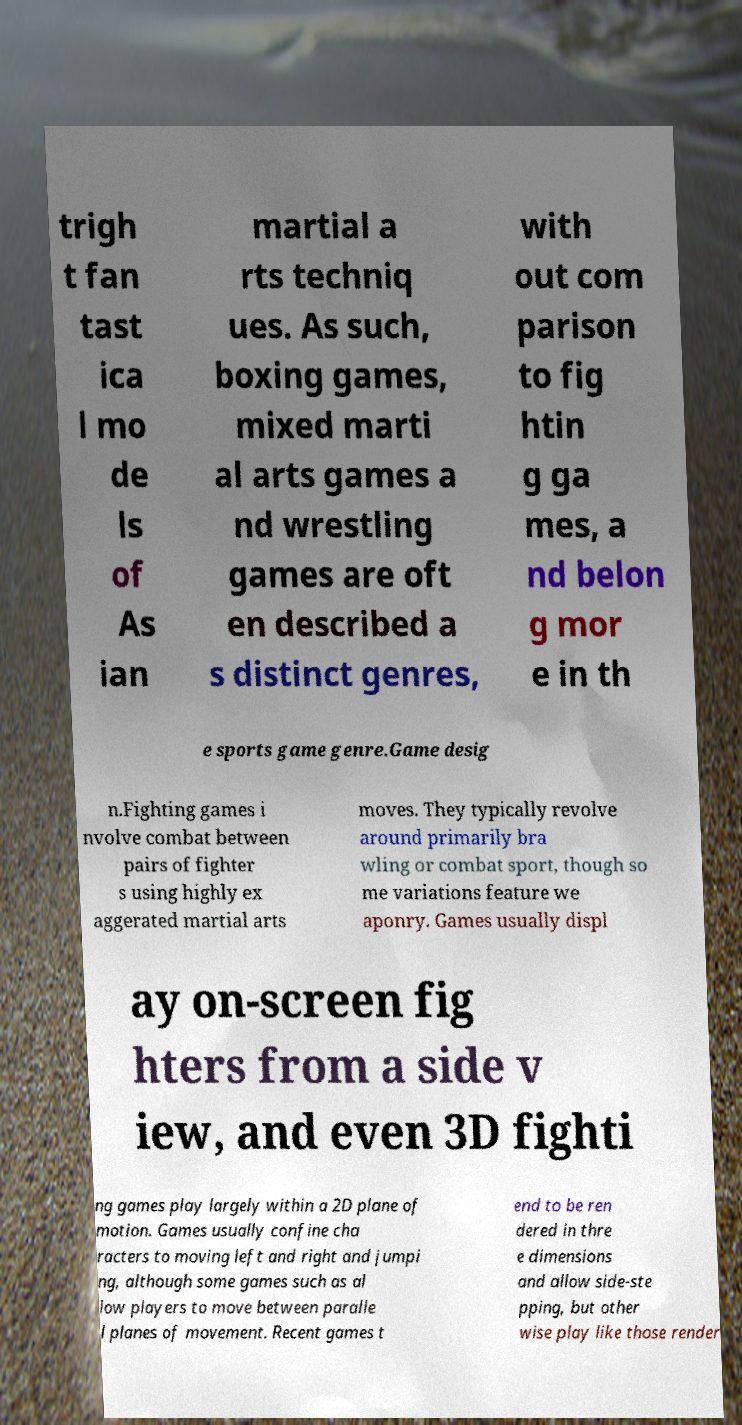There's text embedded in this image that I need extracted. Can you transcribe it verbatim? trigh t fan tast ica l mo de ls of As ian martial a rts techniq ues. As such, boxing games, mixed marti al arts games a nd wrestling games are oft en described a s distinct genres, with out com parison to fig htin g ga mes, a nd belon g mor e in th e sports game genre.Game desig n.Fighting games i nvolve combat between pairs of fighter s using highly ex aggerated martial arts moves. They typically revolve around primarily bra wling or combat sport, though so me variations feature we aponry. Games usually displ ay on-screen fig hters from a side v iew, and even 3D fighti ng games play largely within a 2D plane of motion. Games usually confine cha racters to moving left and right and jumpi ng, although some games such as al low players to move between paralle l planes of movement. Recent games t end to be ren dered in thre e dimensions and allow side-ste pping, but other wise play like those render 